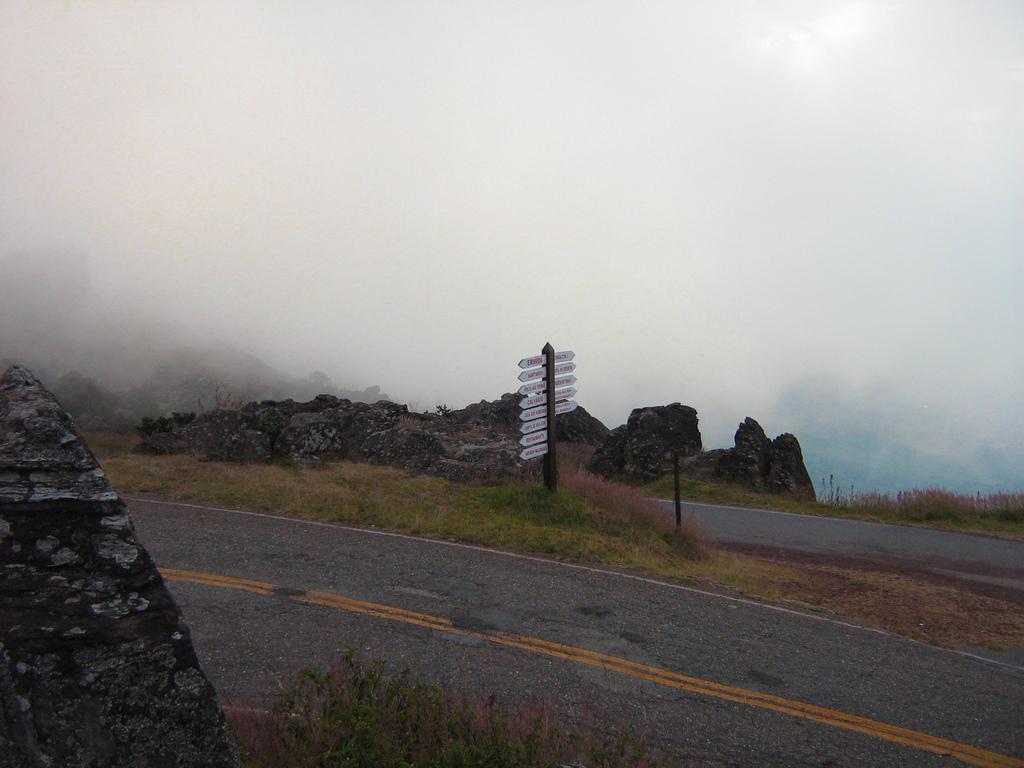Describe this image in one or two sentences. In the image there is a road in the front with plants on either side of it followed by rocks in the back and above its sky with clouds. 